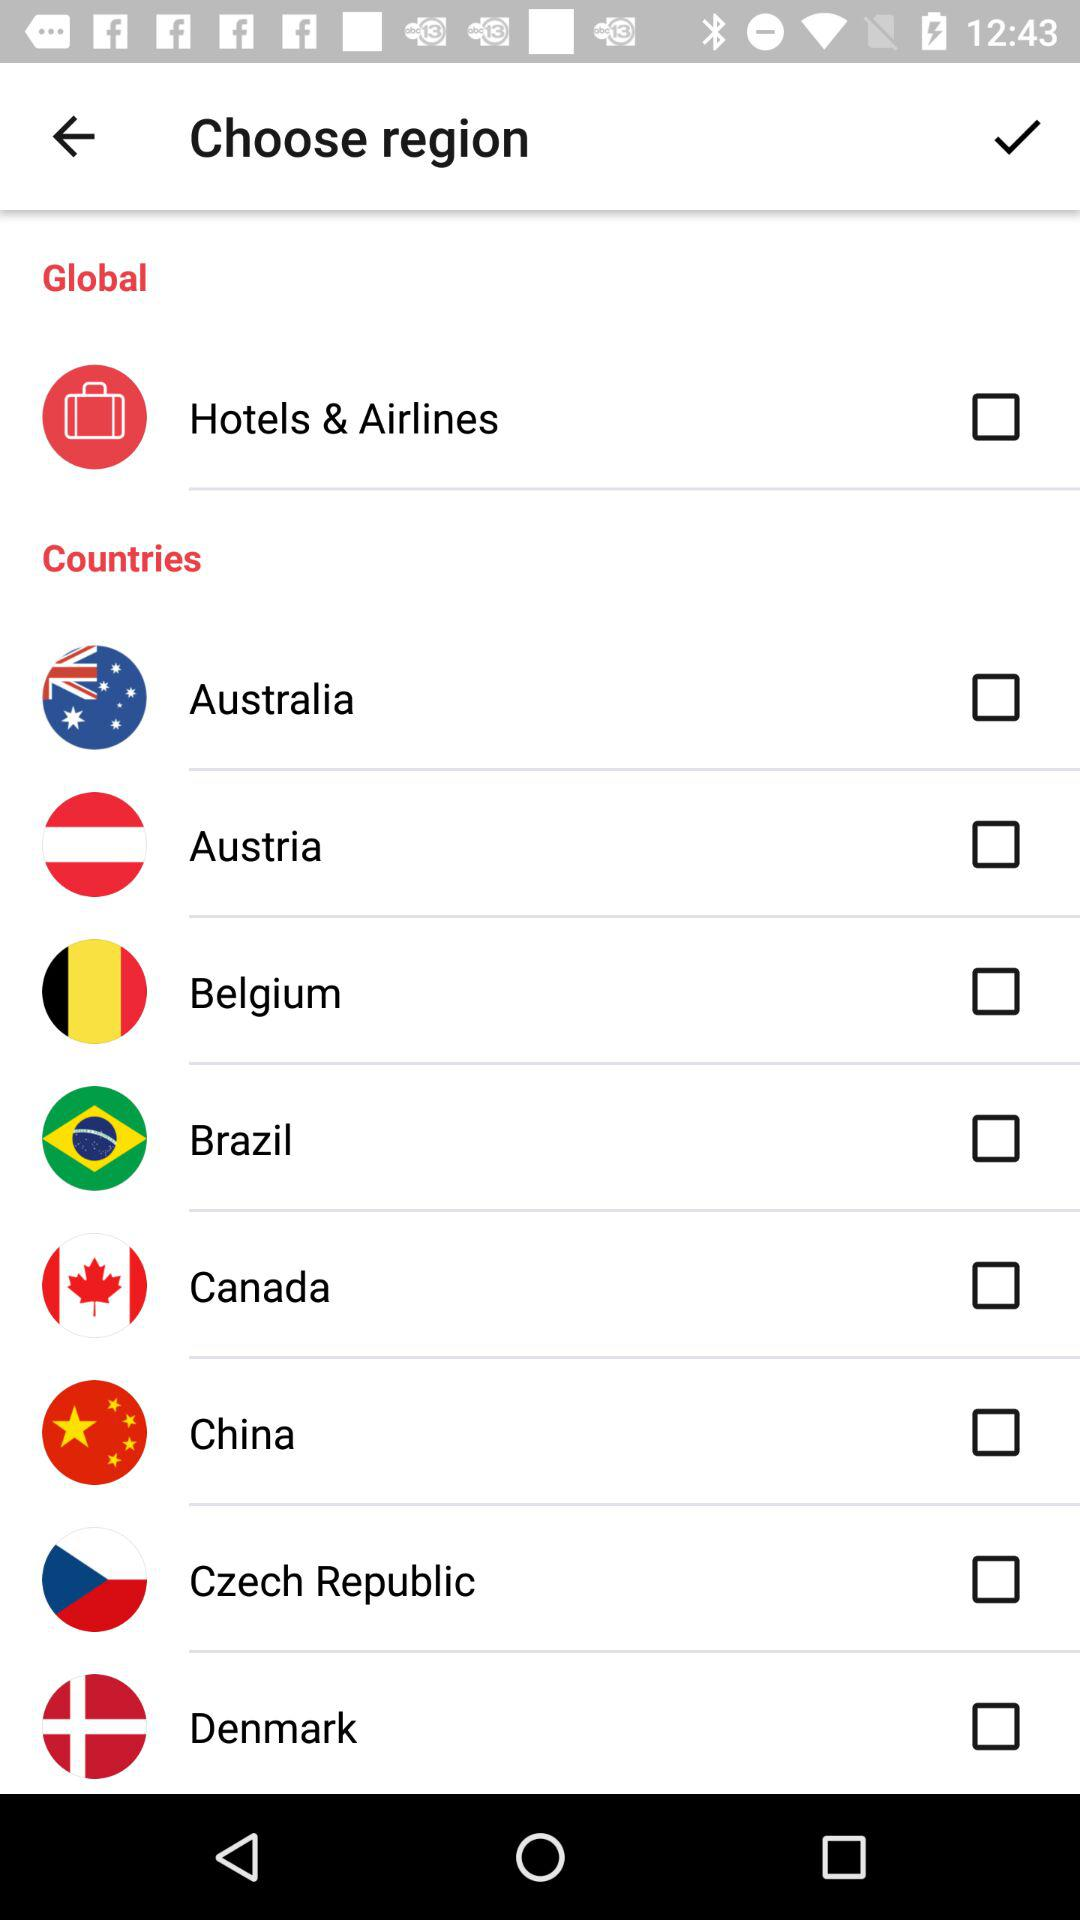What is the current status of China? The current status of China is "off". 